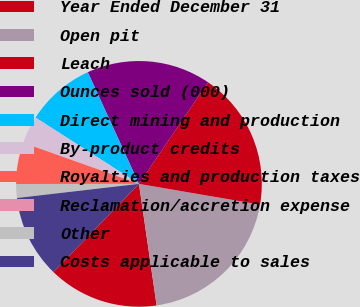Convert chart to OTSL. <chart><loc_0><loc_0><loc_500><loc_500><pie_chart><fcel>Year Ended December 31<fcel>Open pit<fcel>Leach<fcel>Ounces sold (000)<fcel>Direct mining and production<fcel>By-product credits<fcel>Royalties and production taxes<fcel>Reclamation/accretion expense<fcel>Other<fcel>Costs applicable to sales<nl><fcel>14.55%<fcel>20.0%<fcel>18.18%<fcel>16.36%<fcel>9.09%<fcel>3.64%<fcel>5.45%<fcel>0.0%<fcel>1.82%<fcel>10.91%<nl></chart> 